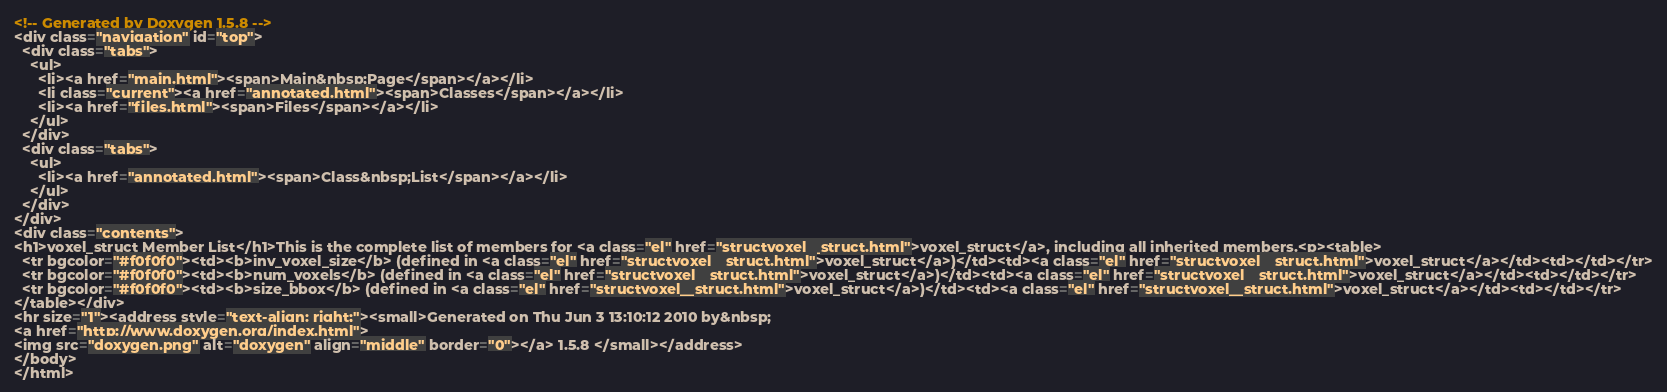Convert code to text. <code><loc_0><loc_0><loc_500><loc_500><_HTML_><!-- Generated by Doxygen 1.5.8 -->
<div class="navigation" id="top">
  <div class="tabs">
    <ul>
      <li><a href="main.html"><span>Main&nbsp;Page</span></a></li>
      <li class="current"><a href="annotated.html"><span>Classes</span></a></li>
      <li><a href="files.html"><span>Files</span></a></li>
    </ul>
  </div>
  <div class="tabs">
    <ul>
      <li><a href="annotated.html"><span>Class&nbsp;List</span></a></li>
    </ul>
  </div>
</div>
<div class="contents">
<h1>voxel_struct Member List</h1>This is the complete list of members for <a class="el" href="structvoxel__struct.html">voxel_struct</a>, including all inherited members.<p><table>
  <tr bgcolor="#f0f0f0"><td><b>inv_voxel_size</b> (defined in <a class="el" href="structvoxel__struct.html">voxel_struct</a>)</td><td><a class="el" href="structvoxel__struct.html">voxel_struct</a></td><td></td></tr>
  <tr bgcolor="#f0f0f0"><td><b>num_voxels</b> (defined in <a class="el" href="structvoxel__struct.html">voxel_struct</a>)</td><td><a class="el" href="structvoxel__struct.html">voxel_struct</a></td><td></td></tr>
  <tr bgcolor="#f0f0f0"><td><b>size_bbox</b> (defined in <a class="el" href="structvoxel__struct.html">voxel_struct</a>)</td><td><a class="el" href="structvoxel__struct.html">voxel_struct</a></td><td></td></tr>
</table></div>
<hr size="1"><address style="text-align: right;"><small>Generated on Thu Jun 3 13:10:12 2010 by&nbsp;
<a href="http://www.doxygen.org/index.html">
<img src="doxygen.png" alt="doxygen" align="middle" border="0"></a> 1.5.8 </small></address>
</body>
</html>
</code> 